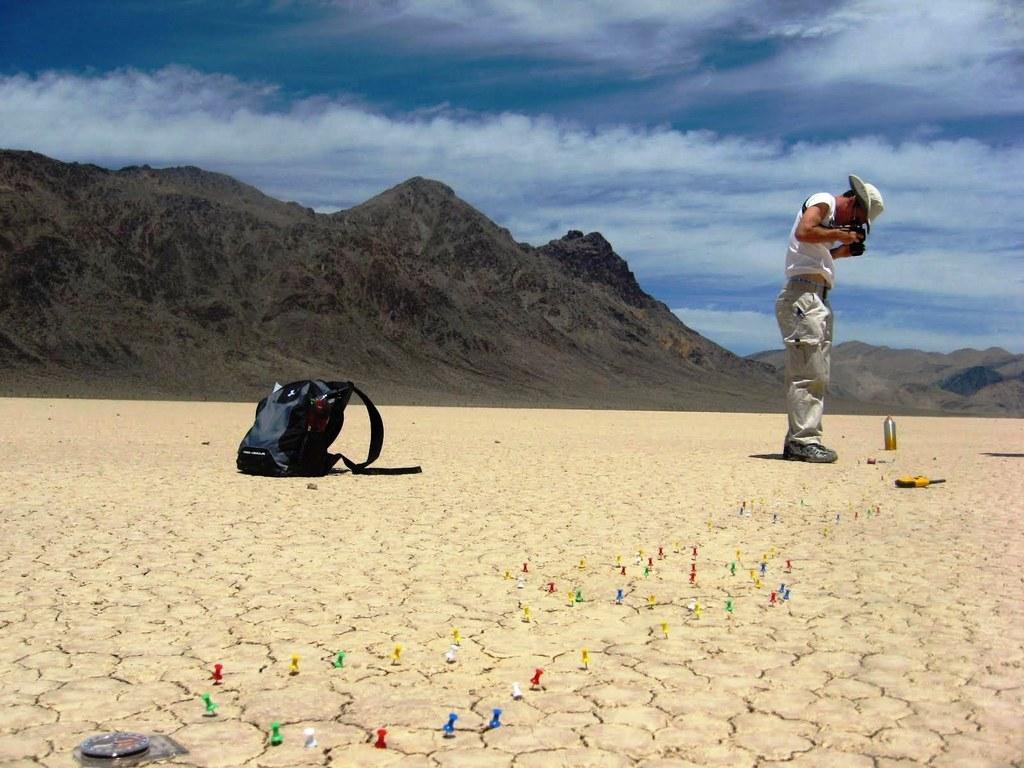How would you summarize this image in a sentence or two? In this image I can see the person standing and holding some object and I can also see the bag, bottle and few objects on the ground. In the background I can see the mountains and the sky is in blue and white color. 